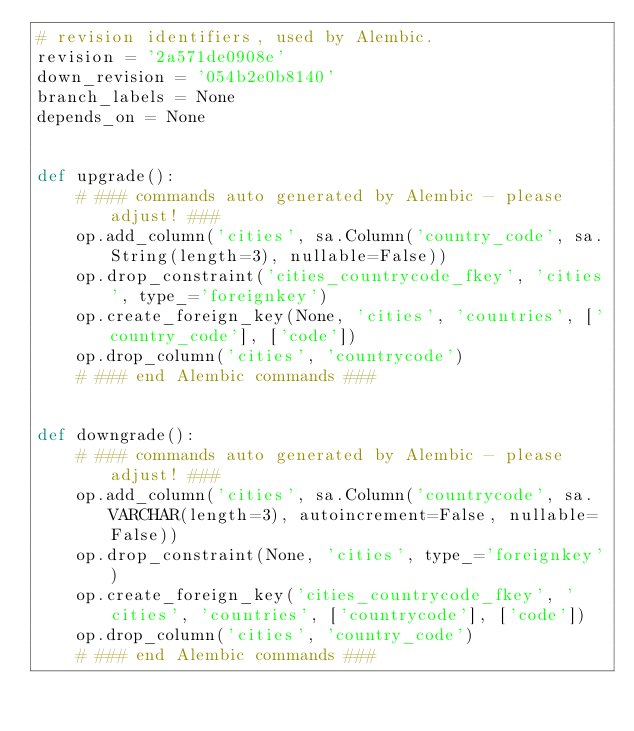<code> <loc_0><loc_0><loc_500><loc_500><_Python_># revision identifiers, used by Alembic.
revision = '2a571de0908e'
down_revision = '054b2e0b8140'
branch_labels = None
depends_on = None


def upgrade():
    # ### commands auto generated by Alembic - please adjust! ###
    op.add_column('cities', sa.Column('country_code', sa.String(length=3), nullable=False))
    op.drop_constraint('cities_countrycode_fkey', 'cities', type_='foreignkey')
    op.create_foreign_key(None, 'cities', 'countries', ['country_code'], ['code'])
    op.drop_column('cities', 'countrycode')
    # ### end Alembic commands ###


def downgrade():
    # ### commands auto generated by Alembic - please adjust! ###
    op.add_column('cities', sa.Column('countrycode', sa.VARCHAR(length=3), autoincrement=False, nullable=False))
    op.drop_constraint(None, 'cities', type_='foreignkey')
    op.create_foreign_key('cities_countrycode_fkey', 'cities', 'countries', ['countrycode'], ['code'])
    op.drop_column('cities', 'country_code')
    # ### end Alembic commands ###
</code> 